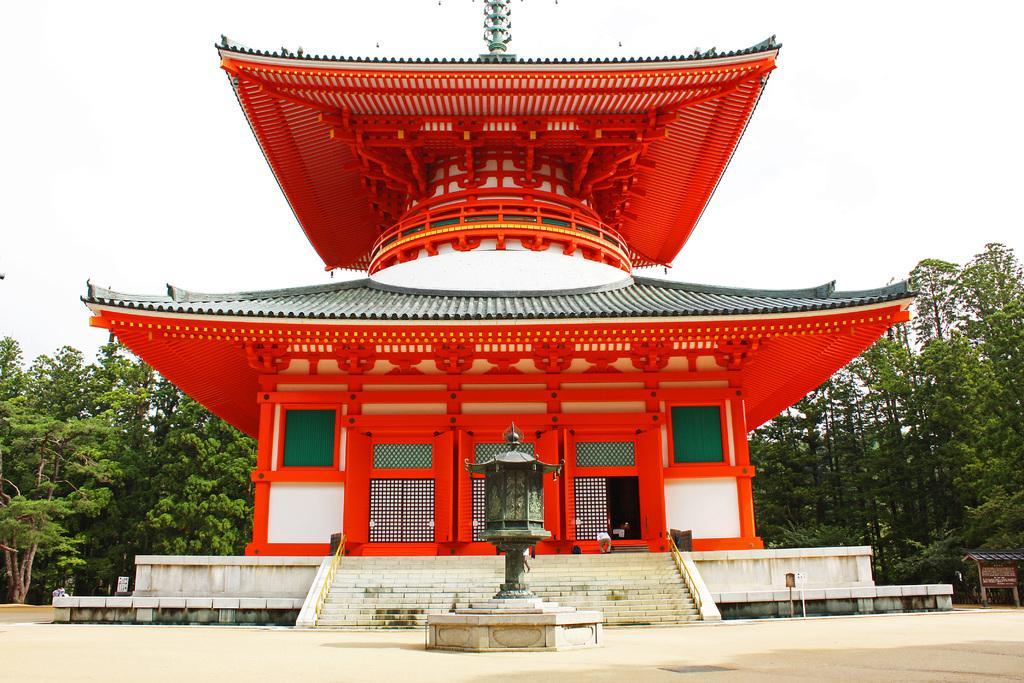Please provide a concise description of this image. This is a building, these are trees and a sky. 